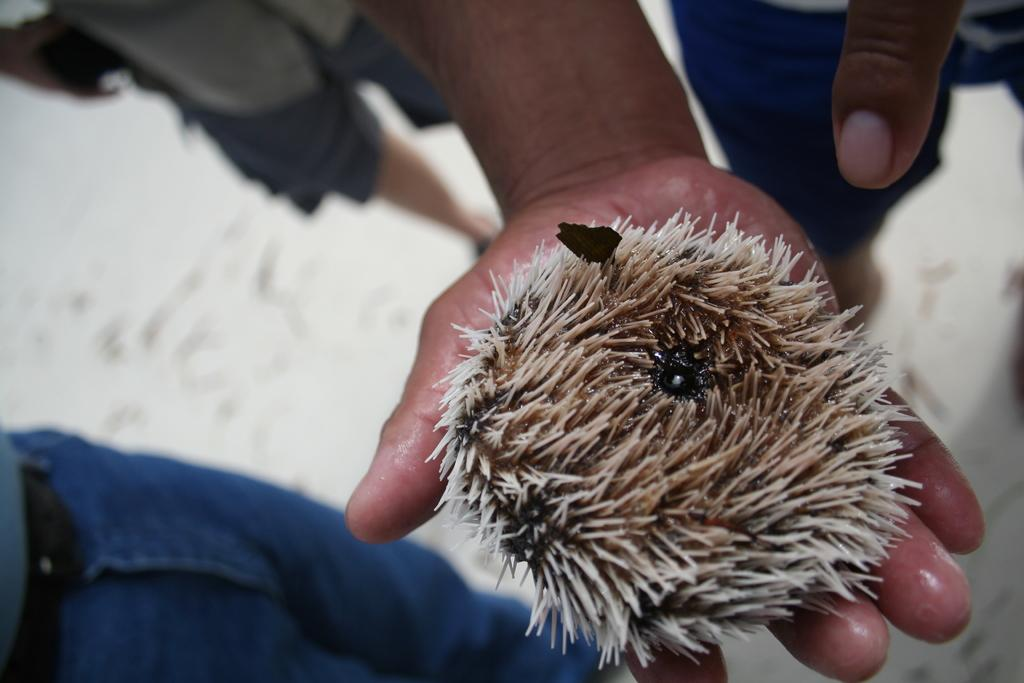What animal is in the image? There is a hedgehog in the image. Where is the hedgehog located? The hedgehog is on a person's hand. Can you describe the people in the image? The legs of people are visible in the image. What is the background of the image like? The background of the image is blurred. What type of cheese is hanging from the hedgehog's spines in the image? There is no cheese present in the image, and the hedgehog's spines are not holding any objects. What sound do the bells make in the image? There are no bells present in the image, so it is not possible to determine the sound they would make. 